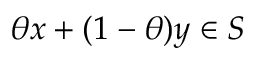Convert formula to latex. <formula><loc_0><loc_0><loc_500><loc_500>\theta x + ( 1 - \theta ) y \in S</formula> 